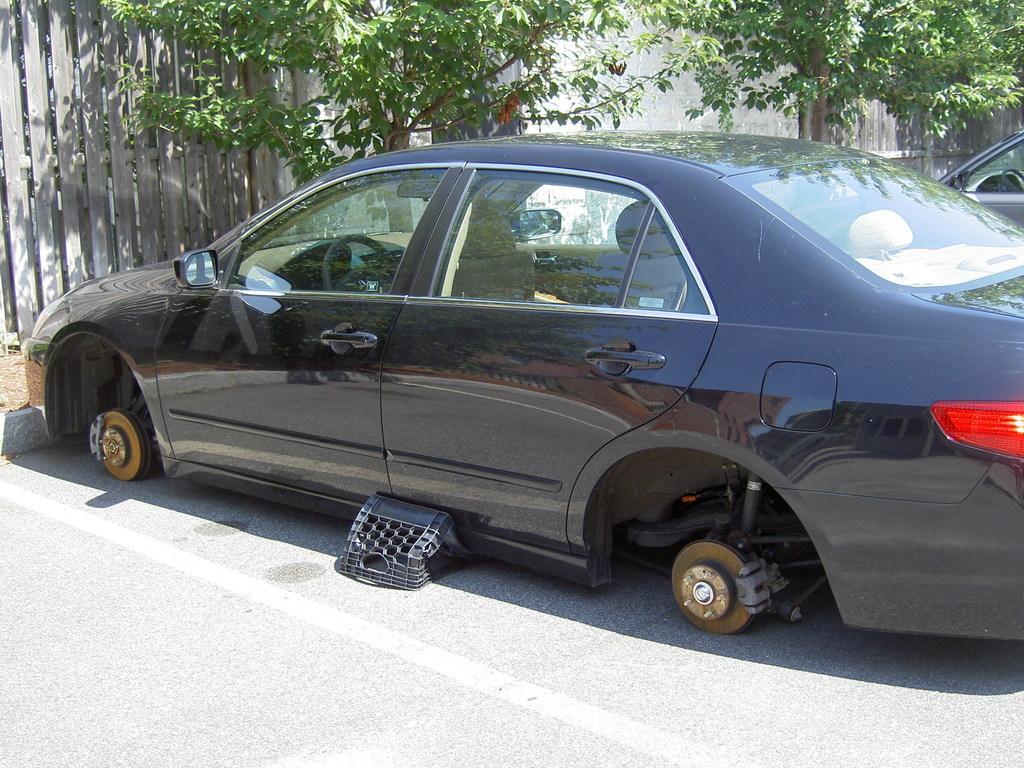Please provide a concise description of this image. In this picture I can see a car without tires and I can see a basket and in the back I can see another car and few trees on the left side and I can see a wall. 